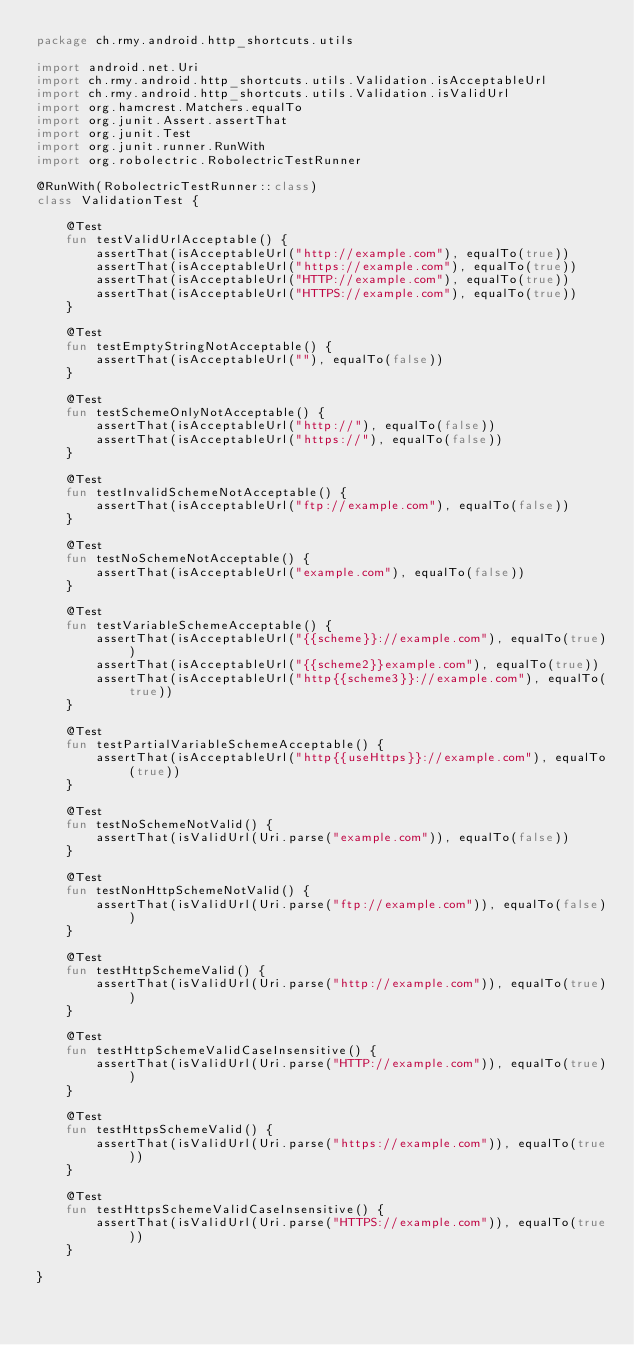Convert code to text. <code><loc_0><loc_0><loc_500><loc_500><_Kotlin_>package ch.rmy.android.http_shortcuts.utils

import android.net.Uri
import ch.rmy.android.http_shortcuts.utils.Validation.isAcceptableUrl
import ch.rmy.android.http_shortcuts.utils.Validation.isValidUrl
import org.hamcrest.Matchers.equalTo
import org.junit.Assert.assertThat
import org.junit.Test
import org.junit.runner.RunWith
import org.robolectric.RobolectricTestRunner

@RunWith(RobolectricTestRunner::class)
class ValidationTest {

    @Test
    fun testValidUrlAcceptable() {
        assertThat(isAcceptableUrl("http://example.com"), equalTo(true))
        assertThat(isAcceptableUrl("https://example.com"), equalTo(true))
        assertThat(isAcceptableUrl("HTTP://example.com"), equalTo(true))
        assertThat(isAcceptableUrl("HTTPS://example.com"), equalTo(true))
    }

    @Test
    fun testEmptyStringNotAcceptable() {
        assertThat(isAcceptableUrl(""), equalTo(false))
    }

    @Test
    fun testSchemeOnlyNotAcceptable() {
        assertThat(isAcceptableUrl("http://"), equalTo(false))
        assertThat(isAcceptableUrl("https://"), equalTo(false))
    }

    @Test
    fun testInvalidSchemeNotAcceptable() {
        assertThat(isAcceptableUrl("ftp://example.com"), equalTo(false))
    }

    @Test
    fun testNoSchemeNotAcceptable() {
        assertThat(isAcceptableUrl("example.com"), equalTo(false))
    }

    @Test
    fun testVariableSchemeAcceptable() {
        assertThat(isAcceptableUrl("{{scheme}}://example.com"), equalTo(true))
        assertThat(isAcceptableUrl("{{scheme2}}example.com"), equalTo(true))
        assertThat(isAcceptableUrl("http{{scheme3}}://example.com"), equalTo(true))
    }

    @Test
    fun testPartialVariableSchemeAcceptable() {
        assertThat(isAcceptableUrl("http{{useHttps}}://example.com"), equalTo(true))
    }

    @Test
    fun testNoSchemeNotValid() {
        assertThat(isValidUrl(Uri.parse("example.com")), equalTo(false))
    }

    @Test
    fun testNonHttpSchemeNotValid() {
        assertThat(isValidUrl(Uri.parse("ftp://example.com")), equalTo(false))
    }

    @Test
    fun testHttpSchemeValid() {
        assertThat(isValidUrl(Uri.parse("http://example.com")), equalTo(true))
    }

    @Test
    fun testHttpSchemeValidCaseInsensitive() {
        assertThat(isValidUrl(Uri.parse("HTTP://example.com")), equalTo(true))
    }

    @Test
    fun testHttpsSchemeValid() {
        assertThat(isValidUrl(Uri.parse("https://example.com")), equalTo(true))
    }

    @Test
    fun testHttpsSchemeValidCaseInsensitive() {
        assertThat(isValidUrl(Uri.parse("HTTPS://example.com")), equalTo(true))
    }

}</code> 